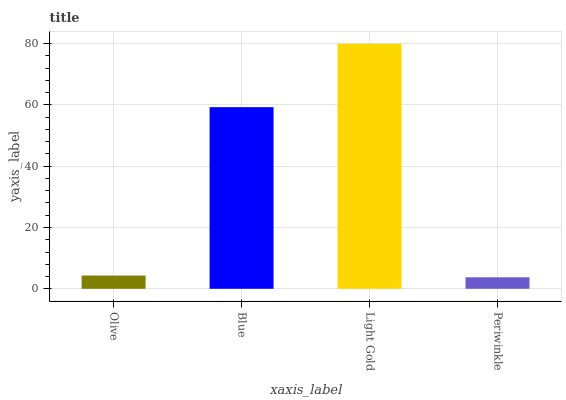Is Periwinkle the minimum?
Answer yes or no. Yes. Is Light Gold the maximum?
Answer yes or no. Yes. Is Blue the minimum?
Answer yes or no. No. Is Blue the maximum?
Answer yes or no. No. Is Blue greater than Olive?
Answer yes or no. Yes. Is Olive less than Blue?
Answer yes or no. Yes. Is Olive greater than Blue?
Answer yes or no. No. Is Blue less than Olive?
Answer yes or no. No. Is Blue the high median?
Answer yes or no. Yes. Is Olive the low median?
Answer yes or no. Yes. Is Olive the high median?
Answer yes or no. No. Is Light Gold the low median?
Answer yes or no. No. 